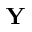Convert formula to latex. <formula><loc_0><loc_0><loc_500><loc_500>Y</formula> 